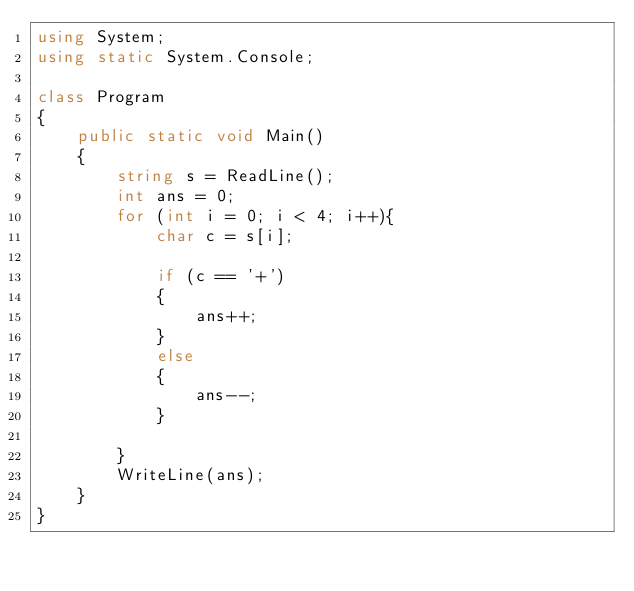Convert code to text. <code><loc_0><loc_0><loc_500><loc_500><_C#_>using System;
using static System.Console;

class Program
{
    public static void Main()
    {
        string s = ReadLine();
        int ans = 0;
        for (int i = 0; i < 4; i++){
            char c = s[i];

            if (c == '+')
            {
                ans++;
            }
            else
            {
                ans--;
            }

        }
        WriteLine(ans);
    }
}
</code> 